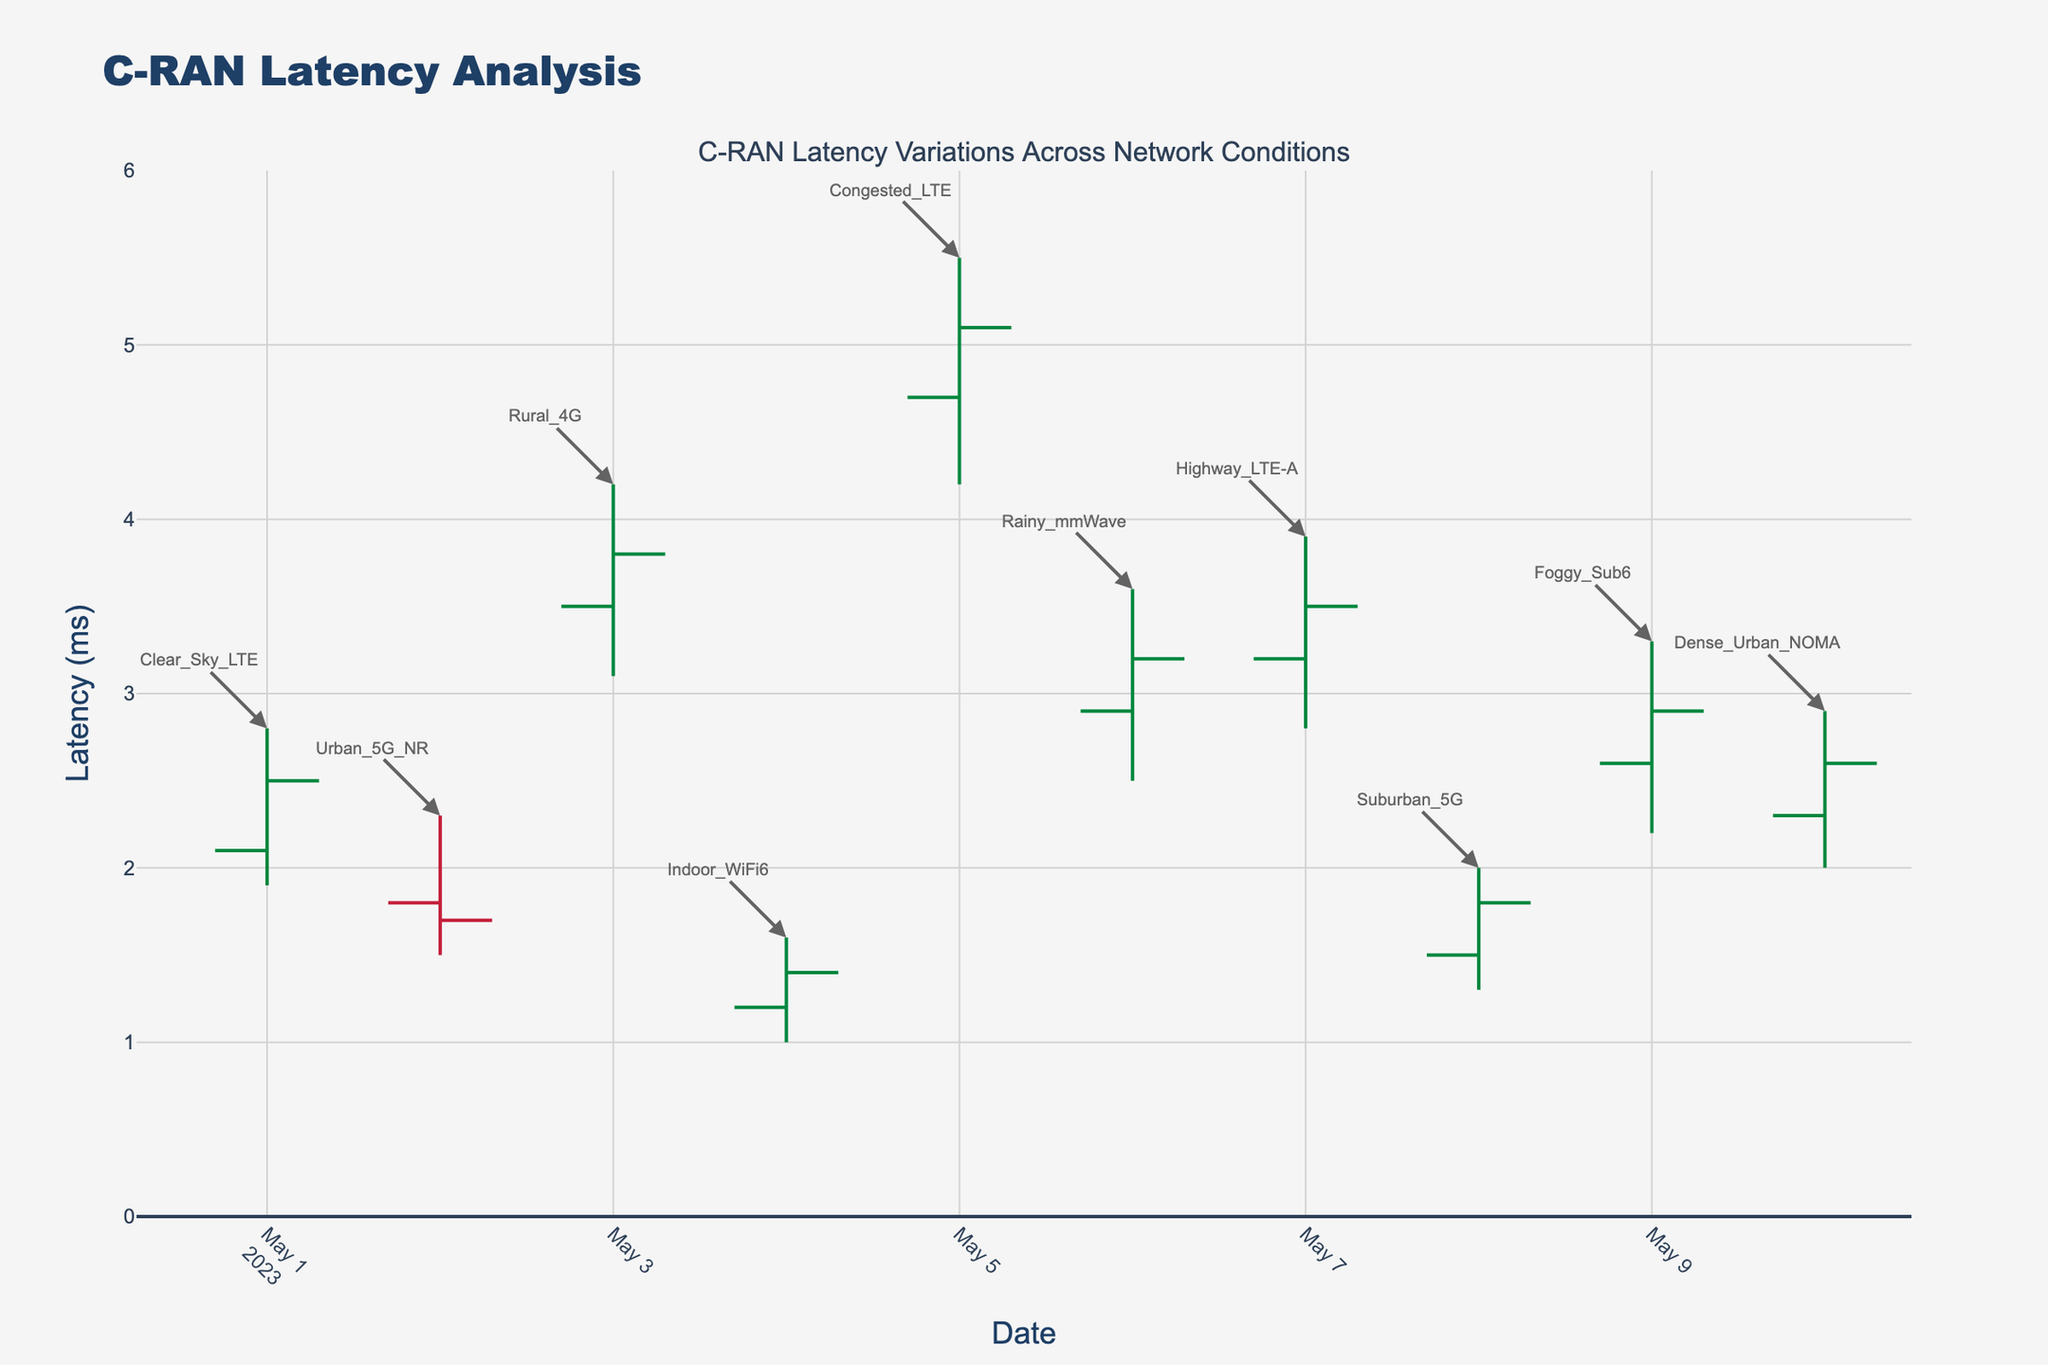What is the title of the plot? The title of the plot is typically displayed at the top center of the figure and is usually in a larger font size to make it stand out. In this case, it is labeled as "C-RAN Latency Analysis".
Answer: C-RAN Latency Analysis What is the y-axis label in the plot? The y-axis label provides the context for the vertical axis, specifying what values are being measured. In this case, the label is "Latency (ms)".
Answer: Latency (ms) Which network condition has the highest "High" latency value? To find this, we look for the highest vertical bar in the plot that extends to the highest point. The network condition linked to this point is labeled "Congested_LTE".
Answer: Congested_LTE What is the range of latency values depicted in the y-axis? The y-axis range shows the minimum and maximum values of latency plotted in the figure. In this case, it ranges from 0 to 6 milliseconds.
Answer: 0 to 6 milliseconds On which date did the "Clear_Sky_LTE" network condition occur, and what was its closing latency value? The "Clear_Sky_LTE" network condition can be identified by looking for the corresponding annotation on the figure. It occurred on "2023-05-01", and the closing latency for that date is 2.5 milliseconds as indicated in the OHLC bar for that date.
Answer: 2023-05-01, 2.5 ms Which date had the lowest "Low" latency value and what is that value? Scan the OHLC bars to find the one that extends to the lowest point on the y-axis. "Indoor_WiFi6" on "2023-05-04" has the lowest "Low" value, which is 1.0 milliseconds.
Answer: 2023-05-04, 1.0 ms How many network conditions showed a decreasing latency trend (Open > Close)? Decreasing trends are shown by bars where the "Open" value is higher than the "Close" value. Counting these bars, we find 3 such network conditions: "Urban_5G_NR", "Indoor_WiFi6", and "Dense_Urban_NOMA".
Answer: 3 Which network condition experienced the largest range in latency values on a single day, and what is that range? To determine this, we need to find the difference between "High" and "Low" for each date and identify the maximum. "Congested_LTE" on "2023-05-05" has the largest range, which is 5.5 - 4.2 = 1.3 milliseconds.
Answer: Congested_LTE, 1.3 ms What is the average closing latency value for all provided dates? Adding up the closing values: 2.5 + 1.7 + 3.8 + 1.4 + 5.1 + 3.2 + 3.5 + 1.8 + 2.9 + 2.6 = 28.5. The number of dates is 10, so the average is 28.5 / 10 = 2.85 milliseconds.
Answer: 2.85 ms Which pair of conditions shows the most significant difference in their closing latency values? To find this, subtract the closing values of each pair and determine the maximum difference. "Congested_LTE" (5.1) and "Indoor_WiFi6" (1.4) shows the largest difference, which is 5.1 - 1.4 = 3.7 milliseconds.
Answer: Congested_LTE and Indoor_WiFi6, 3.7 ms 